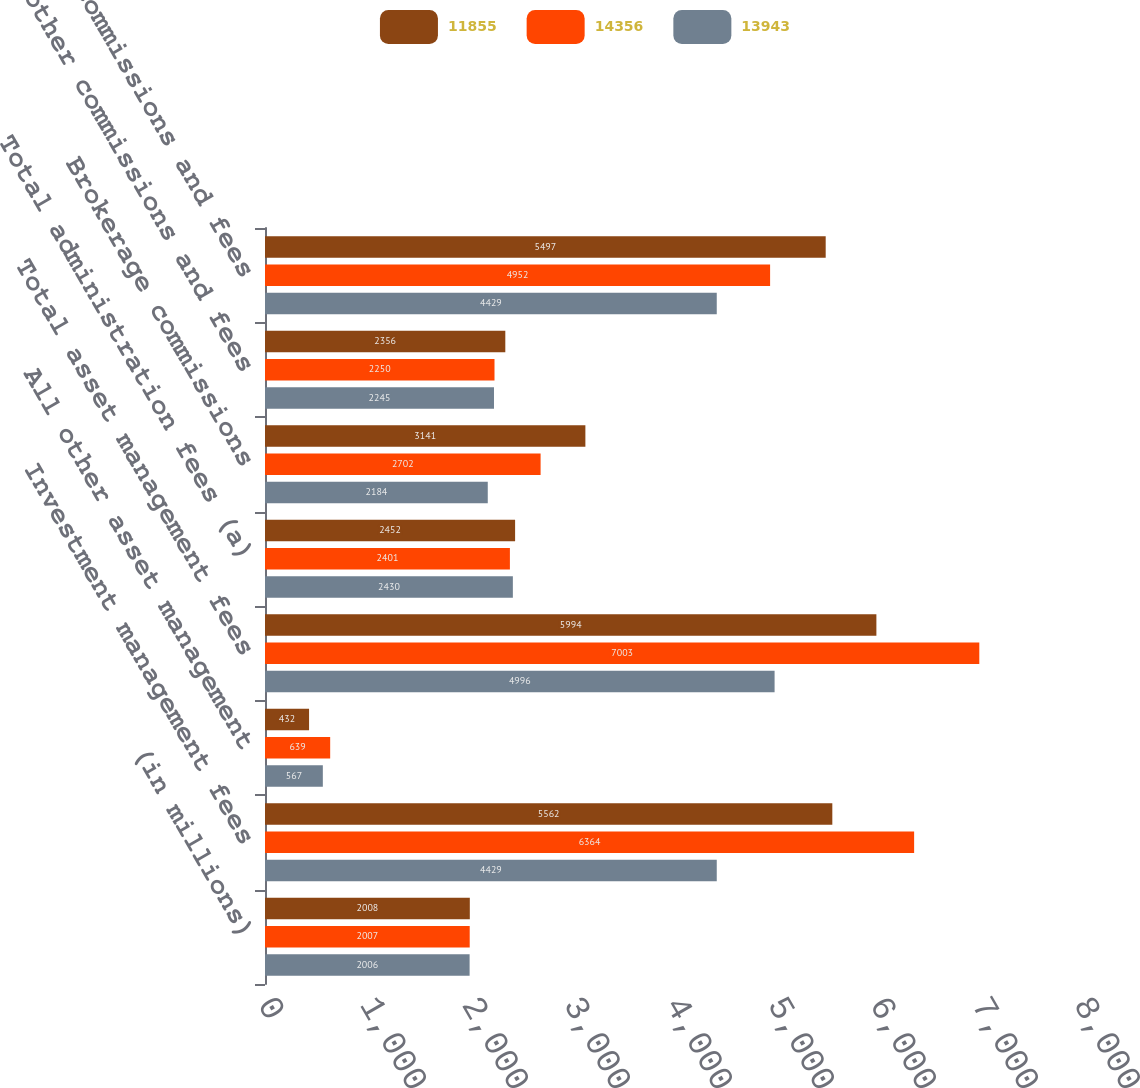Convert chart. <chart><loc_0><loc_0><loc_500><loc_500><stacked_bar_chart><ecel><fcel>(in millions)<fcel>Investment management fees<fcel>All other asset management<fcel>Total asset management fees<fcel>Total administration fees (a)<fcel>Brokerage commissions<fcel>All other commissions and fees<fcel>Total commissions and fees<nl><fcel>11855<fcel>2008<fcel>5562<fcel>432<fcel>5994<fcel>2452<fcel>3141<fcel>2356<fcel>5497<nl><fcel>14356<fcel>2007<fcel>6364<fcel>639<fcel>7003<fcel>2401<fcel>2702<fcel>2250<fcel>4952<nl><fcel>13943<fcel>2006<fcel>4429<fcel>567<fcel>4996<fcel>2430<fcel>2184<fcel>2245<fcel>4429<nl></chart> 